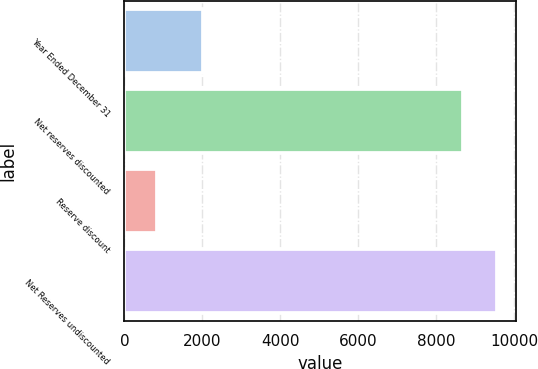<chart> <loc_0><loc_0><loc_500><loc_500><bar_chart><fcel>Year Ended December 31<fcel>Net reserves discounted<fcel>Reserve discount<fcel>Net Reserves undiscounted<nl><fcel>2013<fcel>8684<fcel>837<fcel>9552.4<nl></chart> 